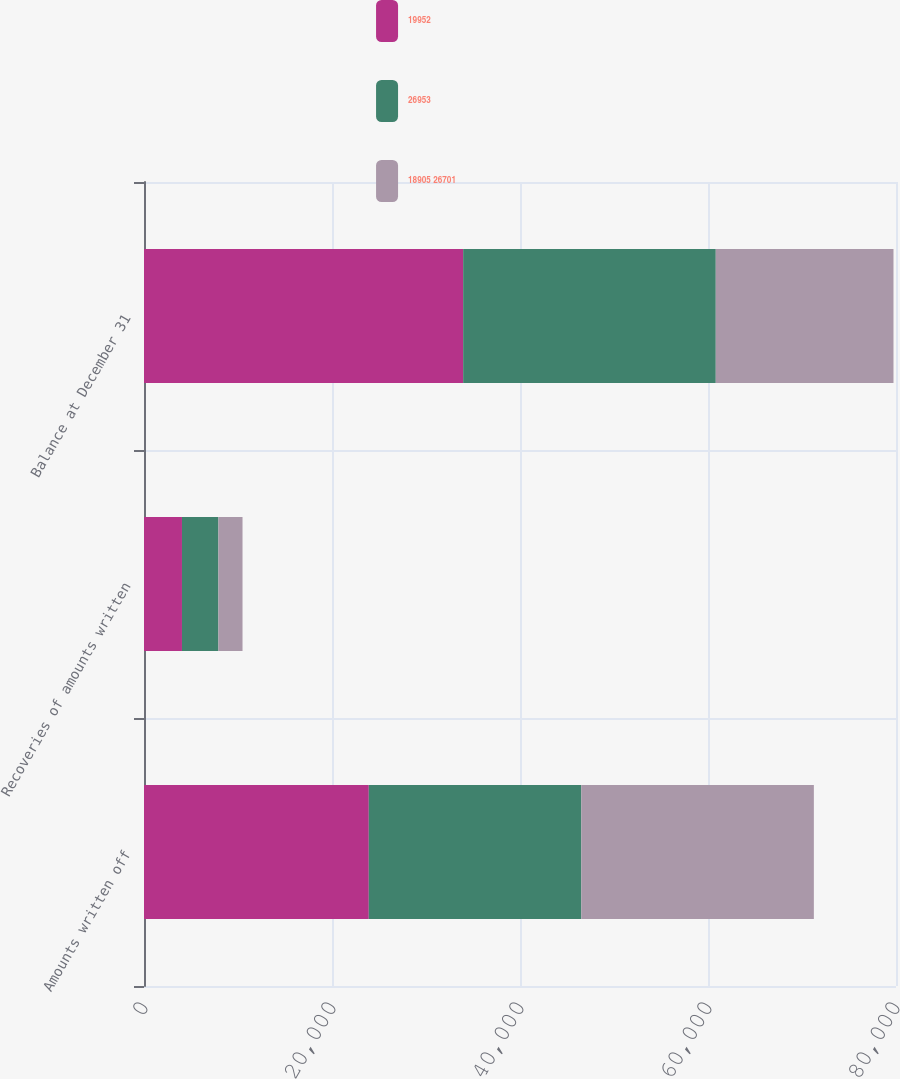Convert chart. <chart><loc_0><loc_0><loc_500><loc_500><stacked_bar_chart><ecel><fcel>Amounts written off<fcel>Recoveries of amounts written<fcel>Balance at December 31<nl><fcel>19952<fcel>23914<fcel>4040<fcel>33953<nl><fcel>26953<fcel>22607<fcel>3875<fcel>26874<nl><fcel>18905 26701<fcel>24741<fcel>2566<fcel>18905<nl></chart> 